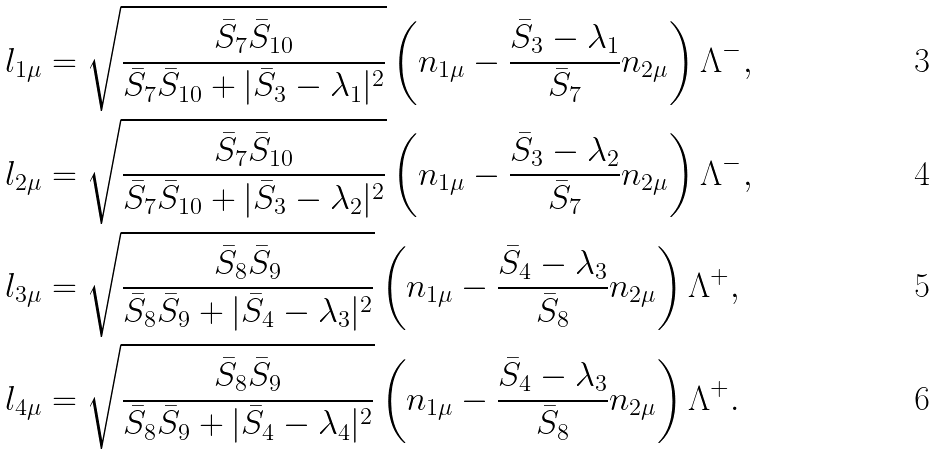<formula> <loc_0><loc_0><loc_500><loc_500>l _ { 1 \mu } & = \sqrt { \frac { \bar { S } _ { 7 } \bar { S } _ { 1 0 } } { \bar { S } _ { 7 } \bar { S } _ { 1 0 } + | \bar { S } _ { 3 } - \lambda _ { 1 } | ^ { 2 } } } \left ( n _ { 1 \mu } - \frac { \bar { S } _ { 3 } - \lambda _ { 1 } } { \bar { S } _ { 7 } } n _ { 2 \mu } \right ) \Lambda ^ { - } , \\ l _ { 2 \mu } & = \sqrt { \frac { \bar { S } _ { 7 } \bar { S } _ { 1 0 } } { \bar { S } _ { 7 } \bar { S } _ { 1 0 } + | \bar { S } _ { 3 } - \lambda _ { 2 } | ^ { 2 } } } \left ( n _ { 1 \mu } - \frac { \bar { S } _ { 3 } - \lambda _ { 2 } } { \bar { S } _ { 7 } } n _ { 2 \mu } \right ) \Lambda ^ { - } , \\ l _ { 3 \mu } & = \sqrt { \frac { \bar { S } _ { 8 } \bar { S } _ { 9 } } { \bar { S } _ { 8 } \bar { S } _ { 9 } + | \bar { S } _ { 4 } - \lambda _ { 3 } | ^ { 2 } } } \left ( n _ { 1 \mu } - \frac { \bar { S } _ { 4 } - \lambda _ { 3 } } { \bar { S } _ { 8 } } n _ { 2 \mu } \right ) \Lambda ^ { + } , \\ l _ { 4 \mu } & = \sqrt { \frac { \bar { S } _ { 8 } \bar { S } _ { 9 } } { \bar { S } _ { 8 } \bar { S } _ { 9 } + | \bar { S } _ { 4 } - \lambda _ { 4 } | ^ { 2 } } } \left ( n _ { 1 \mu } - \frac { \bar { S } _ { 4 } - \lambda _ { 3 } } { \bar { S } _ { 8 } } n _ { 2 \mu } \right ) \Lambda ^ { + } .</formula> 